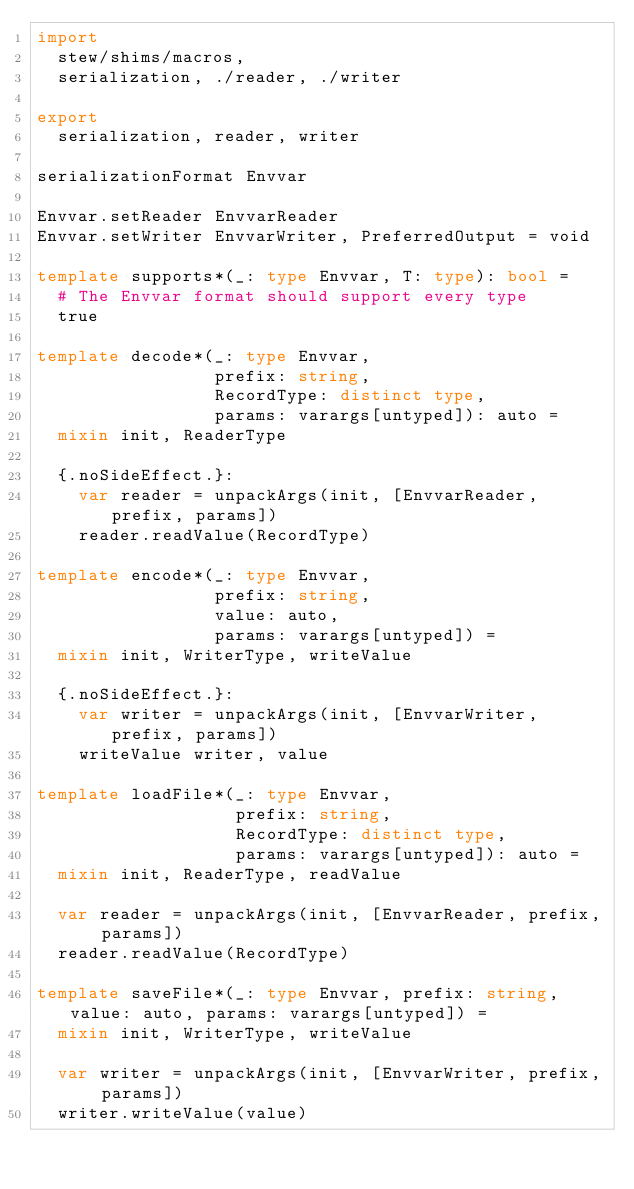<code> <loc_0><loc_0><loc_500><loc_500><_Nim_>import
  stew/shims/macros,
  serialization, ./reader, ./writer

export
  serialization, reader, writer

serializationFormat Envvar

Envvar.setReader EnvvarReader
Envvar.setWriter EnvvarWriter, PreferredOutput = void

template supports*(_: type Envvar, T: type): bool =
  # The Envvar format should support every type
  true

template decode*(_: type Envvar,
                 prefix: string,
                 RecordType: distinct type,
                 params: varargs[untyped]): auto =
  mixin init, ReaderType

  {.noSideEffect.}:
    var reader = unpackArgs(init, [EnvvarReader, prefix, params])
    reader.readValue(RecordType)

template encode*(_: type Envvar,
                 prefix: string,
                 value: auto,
                 params: varargs[untyped]) =
  mixin init, WriterType, writeValue

  {.noSideEffect.}:
    var writer = unpackArgs(init, [EnvvarWriter, prefix, params])
    writeValue writer, value

template loadFile*(_: type Envvar,
                   prefix: string,
                   RecordType: distinct type,
                   params: varargs[untyped]): auto =
  mixin init, ReaderType, readValue

  var reader = unpackArgs(init, [EnvvarReader, prefix, params])
  reader.readValue(RecordType)

template saveFile*(_: type Envvar, prefix: string, value: auto, params: varargs[untyped]) =
  mixin init, WriterType, writeValue

  var writer = unpackArgs(init, [EnvvarWriter, prefix, params])
  writer.writeValue(value)
</code> 